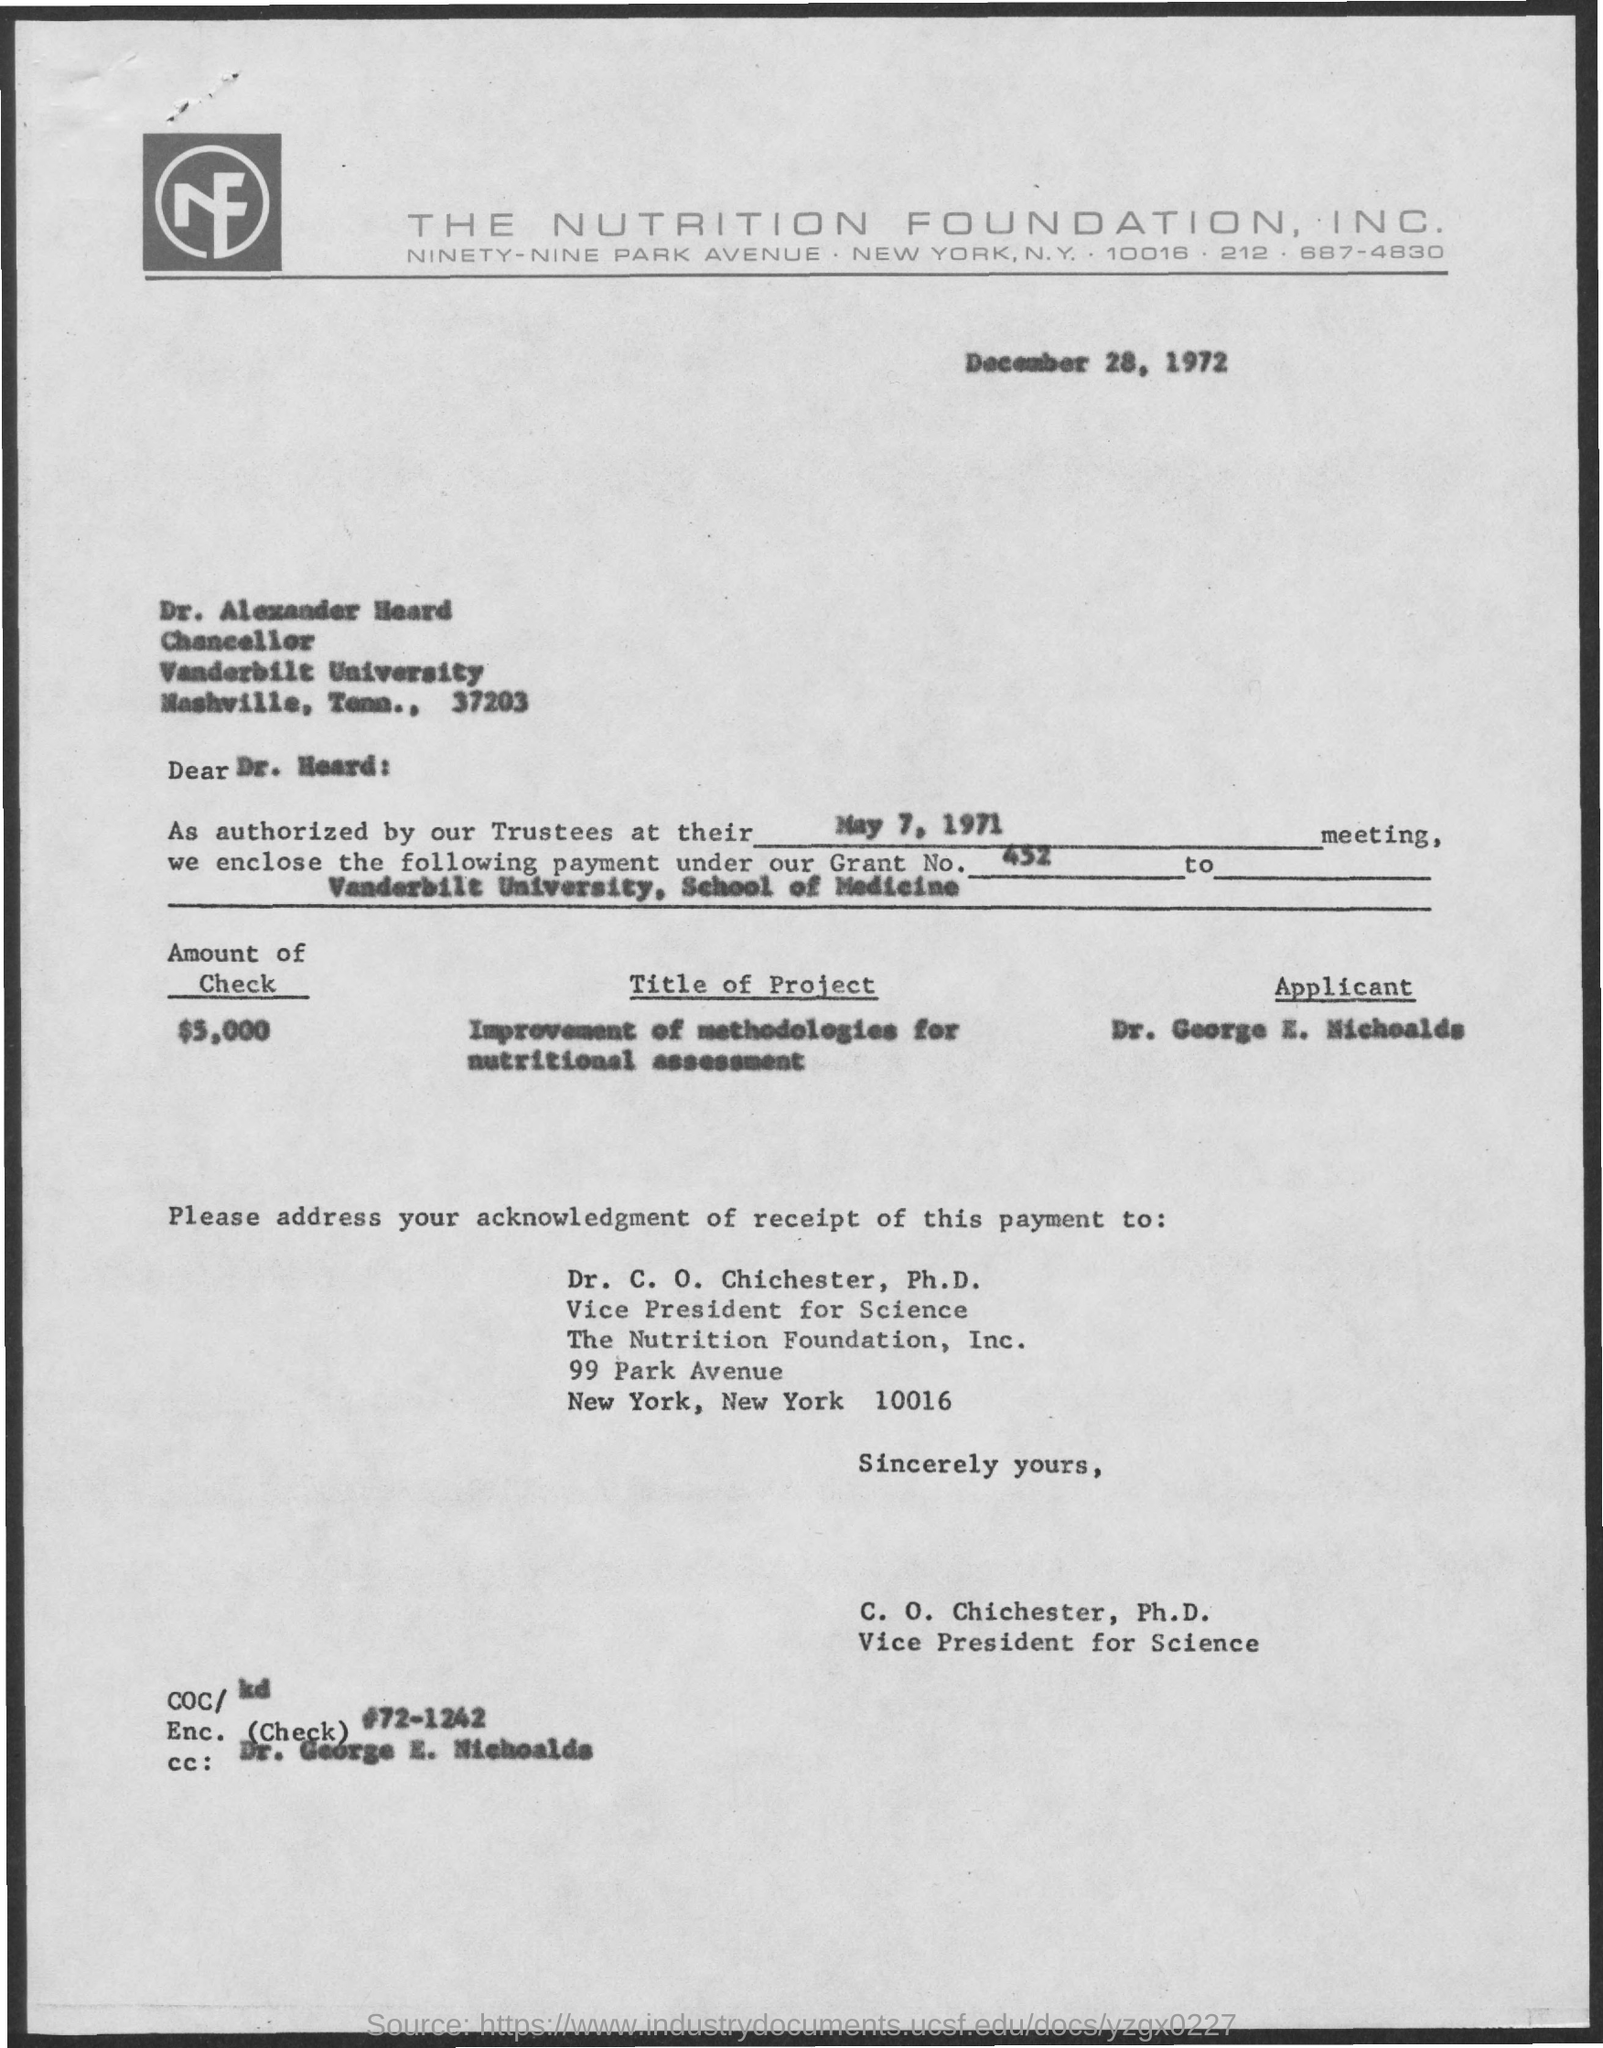Highlight a few significant elements in this photo. The name of the applicant is Dr. George E. Nicholads. Dr. George E. Nichoalds is mentioned in the CC: section. Vanderbilt University is named after Cornelius Vanderbilt, an American businessman and philanthropist. The grant number is 452. The title of the project is to improve the methodologies for nutritional assessment. 